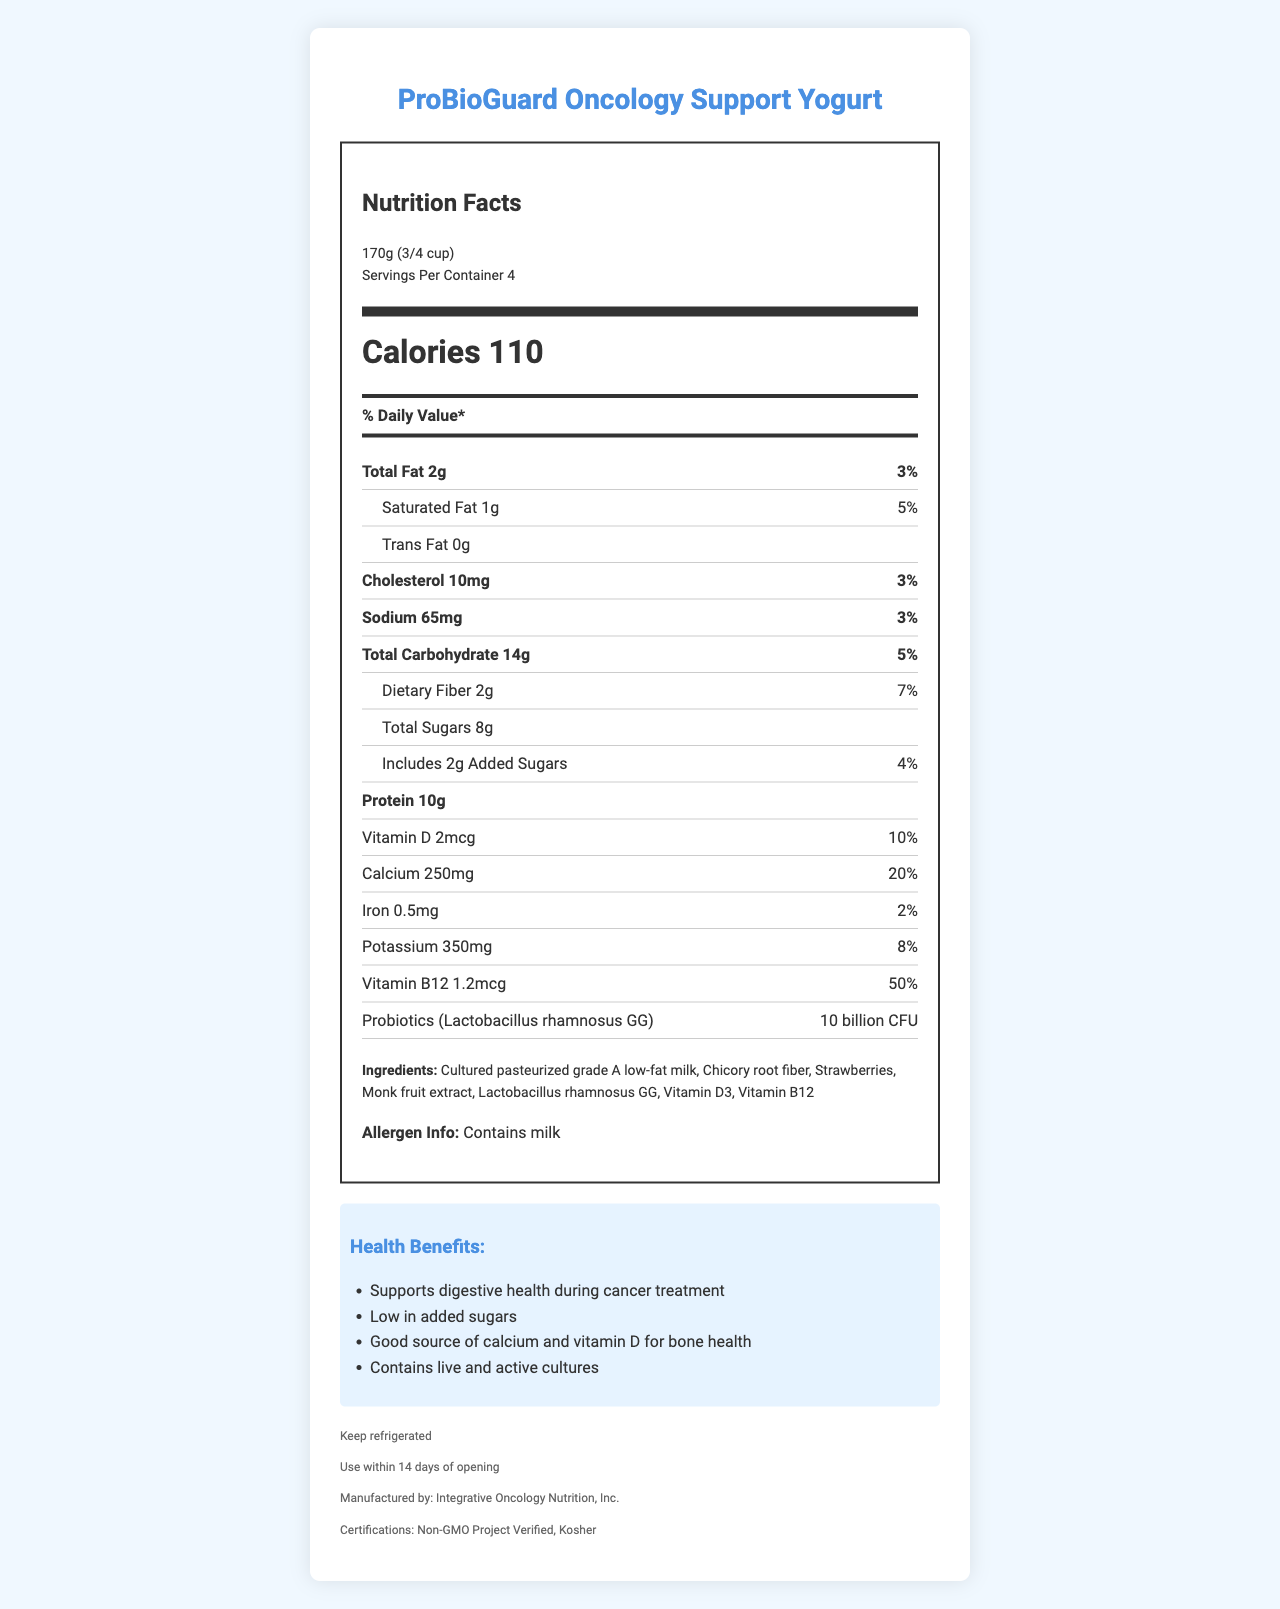what is the serving size? The serving size is explicitly mentioned in the document as "170g (3/4 cup)."
Answer: 170g (3/4 cup) what are the daily values of saturated fat and cholesterol? The daily values for saturated fat and cholesterol are provided as 5% and 3% respectively in the document.
Answer: Saturated Fat: 5%, Cholesterol: 3% how many servings are there in one container? The document states that there are 4 servings per container.
Answer: 4 what is the total carbohydrate content per serving? The document indicates the total carbohydrate amount per serving is 14g.
Answer: 14g what is the main probiotic strain in the yogurt? The main probiotic strain explicitly mentioned in the document is Lactobacillus rhamnosus GG.
Answer: Lactobacillus rhamnosus GG What is the amount of Vitamin B12 per serving? The document indicates that there are 1.2mcg of Vitamin B12 per serving.
Answer: 1.2mcg How much fiber does the yogurt contain per serving? The fiber content per serving is listed as 2g in the document.
Answer: 2g Which of the following are listed health claims of the yogurt? 
A. Supports immune health
B. Supports digestive health during cancer treatment
C. Low in added sugars
D. Good source of vitamin C The health claims listed in the document include “Supports digestive health during cancer treatment”, “Low in added sugars” and “Good source of calcium and vitamin D for bone health”. ‘Supports immune health’ and ‘Good source of vitamin C’ are not mentioned.
Answer: B, C, D Which certification is NOT mentioned in the document?
A. Non-GMO Project Verified
B. Organic
C. Kosher The document mentions the yogurt is Non-GMO Project Verified and Kosher, but does not mention anything about being Organic.
Answer: B. Organic Is the yogurt suitable for someone who is lactose intolerant? The yogurt contains cultured pasteurized grade A low-fat milk, which includes lactose, thus it may not be suitable for someone who is lactose intolerant.
Answer: No Summarize the nutritional contents and health benefits of the ProBioGuard Oncology Support Yogurt. The summarized document indicates the product's nutritional values, probiotic content, and health benefits including digestive support during cancer treatment and certifications for quality assurance.
Answer: The ProBioGuard Oncology Support Yogurt is a probiotic-enhanced, low-sugar yogurt designed to support gut health during cancer treatment. Each 170g serving contains 110 calories, 2g of total fat, 14g of total carbohydrates, 10g of protein, and is a good source of calcium, vitamin D, and vitamin B12. It also contains Lactobacillus rhamnosus GG with 10 billion CFU to promote digestive health. The product is low in added sugars, contains live active cultures, and is certified by Non-GMO Project Verified and Kosher What is the ratio of total sugars to added sugars in each serving? There are 8g of total sugars and 2g of added sugars per serving, making the ratio 4:1.
Answer: 4:1 What does the storage instruction say? The document lists "Keep refrigerated" as the storage instruction.
Answer: Keep refrigerated Who manufactures the ProBioGuard Oncology Support Yogurt? The manufacturer is explicitly listed as Integrative Oncology Nutrition, Inc.
Answer: Integrative Oncology Nutrition, Inc. What are the yearly sales of the yogurt? The document does not provide any details about the sales figures of the yogurt, so this information cannot be determined.
Answer: Not enough information 